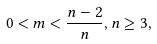<formula> <loc_0><loc_0><loc_500><loc_500>0 < m < \frac { n - 2 } { n } , n \geq 3 ,</formula> 